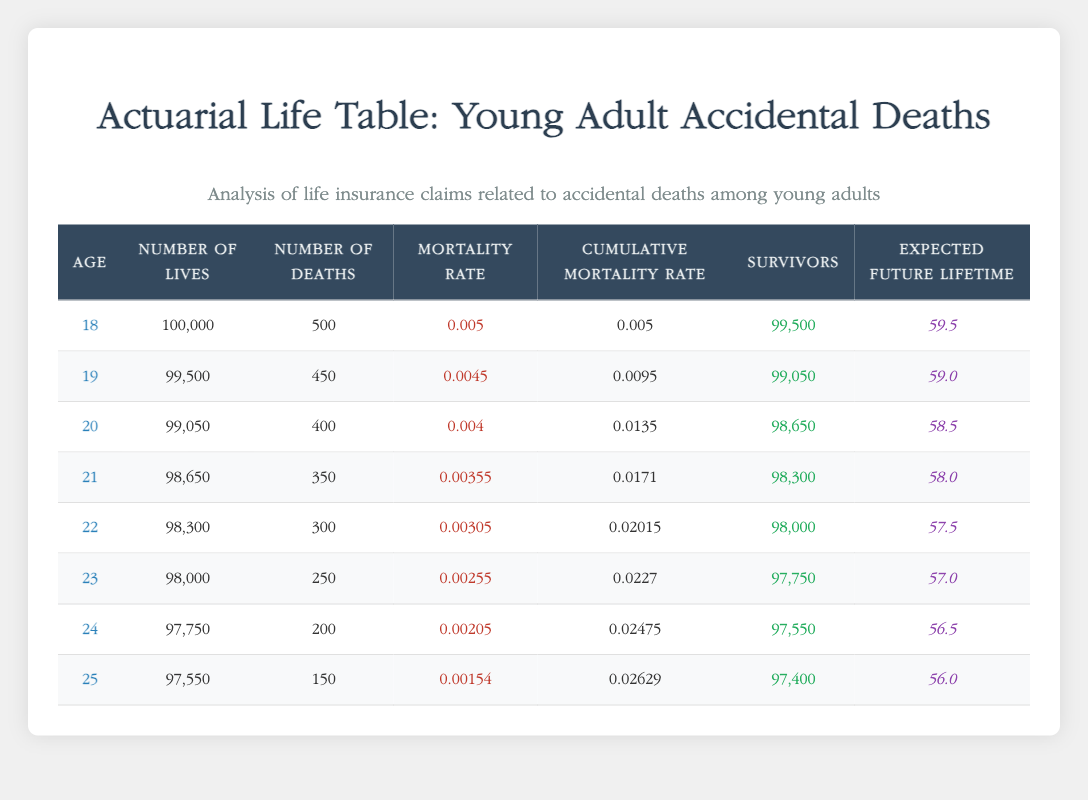What is the mortality rate for 20-year-olds? The mortality rate for 20-year-olds is given directly in the table under the "Mortality Rate" column for age 20, which is 0.004.
Answer: 0.004 How many survivors are there at age 22? The number of survivors at age 22 is listed in the "Survivors" column for age 22, which shows 98,000 individuals.
Answer: 98,000 What is the cumulative mortality rate for 24-year-olds? The cumulative mortality rate for 24-year-olds is directly provided in the table under the "Cumulative Mortality Rate" column for age 24, which is 0.02475.
Answer: 0.02475 What is the expected future lifetime for 18-year-olds compared to 25-year-olds? The expected future lifetime for 18-year-olds is 59.5 years, while for 25-year-olds it is 56.0 years. The difference is calculated as 59.5 - 56.0 = 3.5 years.
Answer: 3.5 years How many deaths occurred between the ages of 18 and 22? We add the number of deaths for ages 18 to 22: 500 (age 18) + 450 (age 19) + 400 (age 20) + 350 (age 21) + 300 (age 22) = 2000 deaths total.
Answer: 2000 deaths Is the mortality rate higher for 19-year-olds than for 21-year-olds? The mortality rate for 19-year-olds is 0.0045, while for 21-year-olds it is 0.00355. Since 0.0045 is greater than 0.00355, the statement is true.
Answer: Yes What percentage of the original 18-year-old population survives until age 25? To find the percentage, we consider the survivors at age 25 (97,400) out of the original 100,000 18-year-olds. This is calculated as (97,400 / 100,000) * 100 = 97.4%.
Answer: 97.4% What is the total number of lives from ages 23 to 25? The total lives for these ages are: 98,000 (age 23) + 97,750 (age 24) + 97,550 (age 25) = 293,300 lives total.
Answer: 293,300 lives Are there more than 300 deaths at age 22? The number of deaths recorded for age 22 is 300. Since the query is looking for "more than," and 300 is not more than 300, the statement is false.
Answer: No 